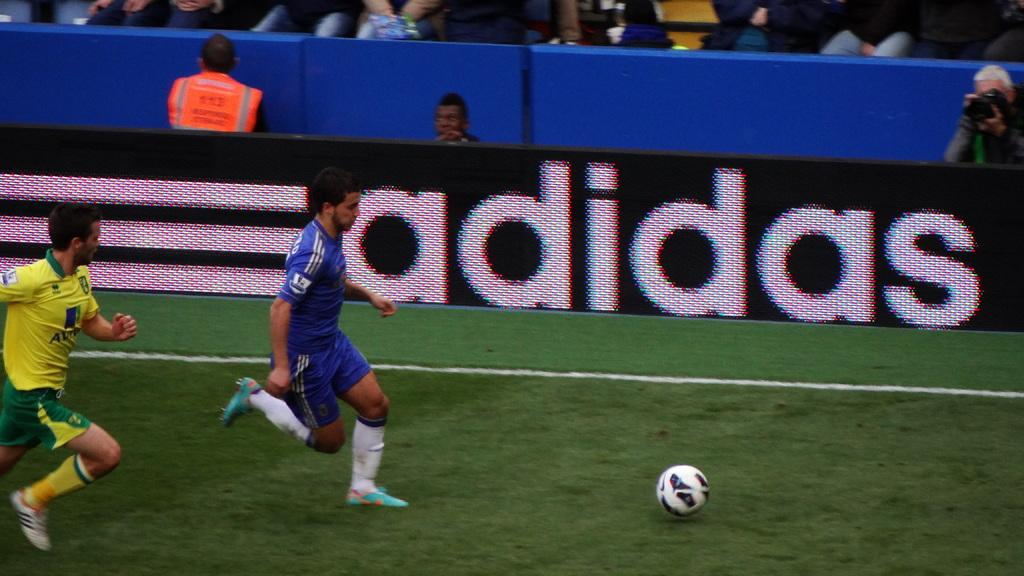<image>
Provide a brief description of the given image. Two soccer players are running in front of an Adidas sign. 